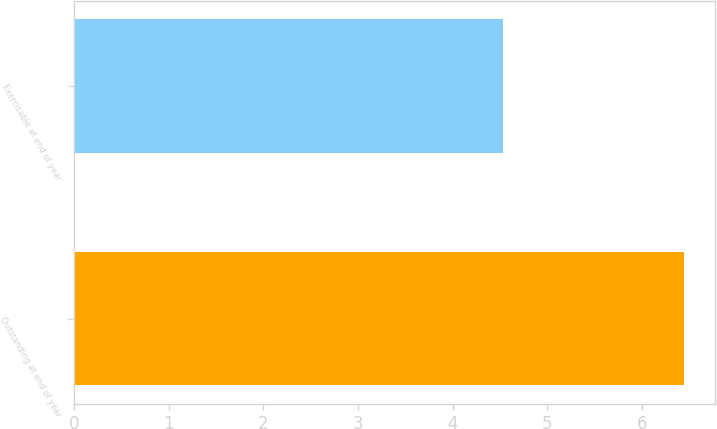<chart> <loc_0><loc_0><loc_500><loc_500><bar_chart><fcel>Outstanding at end of year<fcel>Exercisable at end of year<nl><fcel>6.45<fcel>4.53<nl></chart> 